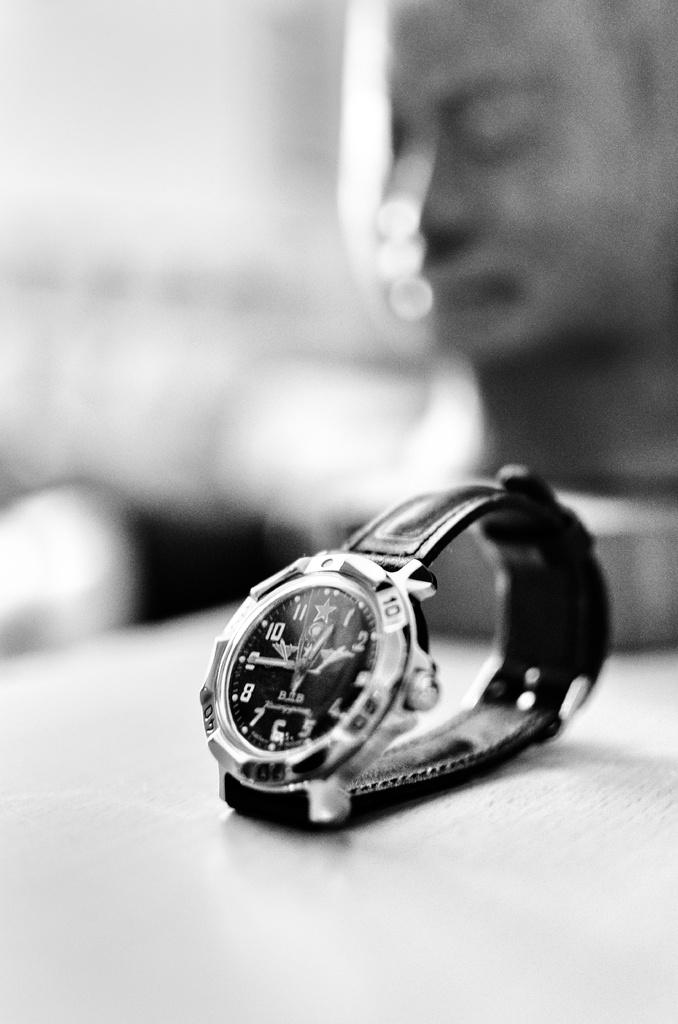<image>
Create a compact narrative representing the image presented. A watch that is showing the time as 12:45 